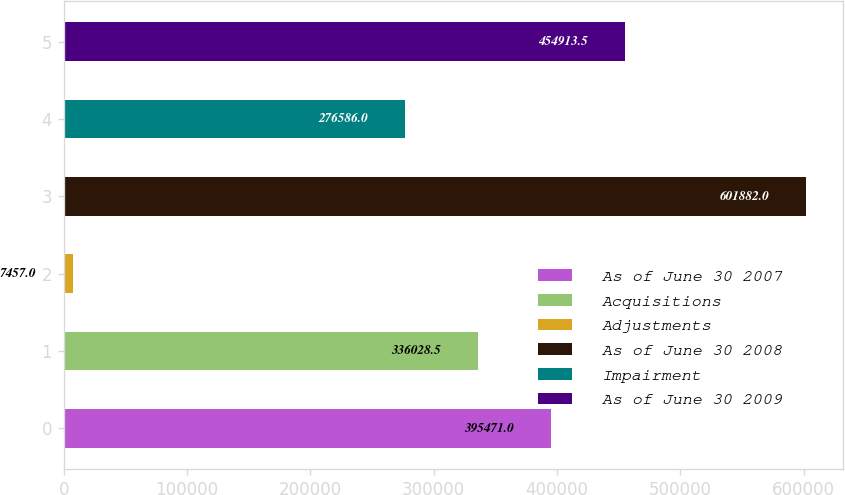Convert chart to OTSL. <chart><loc_0><loc_0><loc_500><loc_500><bar_chart><fcel>As of June 30 2007<fcel>Acquisitions<fcel>Adjustments<fcel>As of June 30 2008<fcel>Impairment<fcel>As of June 30 2009<nl><fcel>395471<fcel>336028<fcel>7457<fcel>601882<fcel>276586<fcel>454914<nl></chart> 